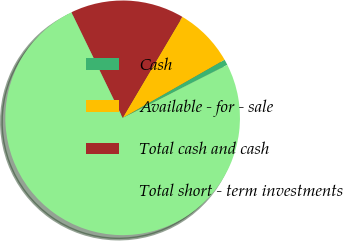Convert chart. <chart><loc_0><loc_0><loc_500><loc_500><pie_chart><fcel>Cash<fcel>Available - for - sale<fcel>Total cash and cash<fcel>Total short - term investments<nl><fcel>0.8%<fcel>8.25%<fcel>15.69%<fcel>75.26%<nl></chart> 